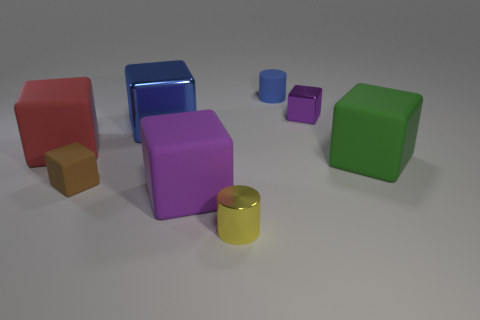Subtract all purple metal blocks. How many blocks are left? 5 Subtract all blue cylinders. How many purple cubes are left? 2 Subtract 4 blocks. How many blocks are left? 2 Add 2 large metallic cylinders. How many objects exist? 10 Subtract all green cubes. How many cubes are left? 5 Subtract all cylinders. How many objects are left? 6 Subtract all blue cubes. Subtract all cyan cylinders. How many cubes are left? 5 Add 8 big metal blocks. How many big metal blocks exist? 9 Subtract 0 brown balls. How many objects are left? 8 Subtract all cylinders. Subtract all big shiny things. How many objects are left? 5 